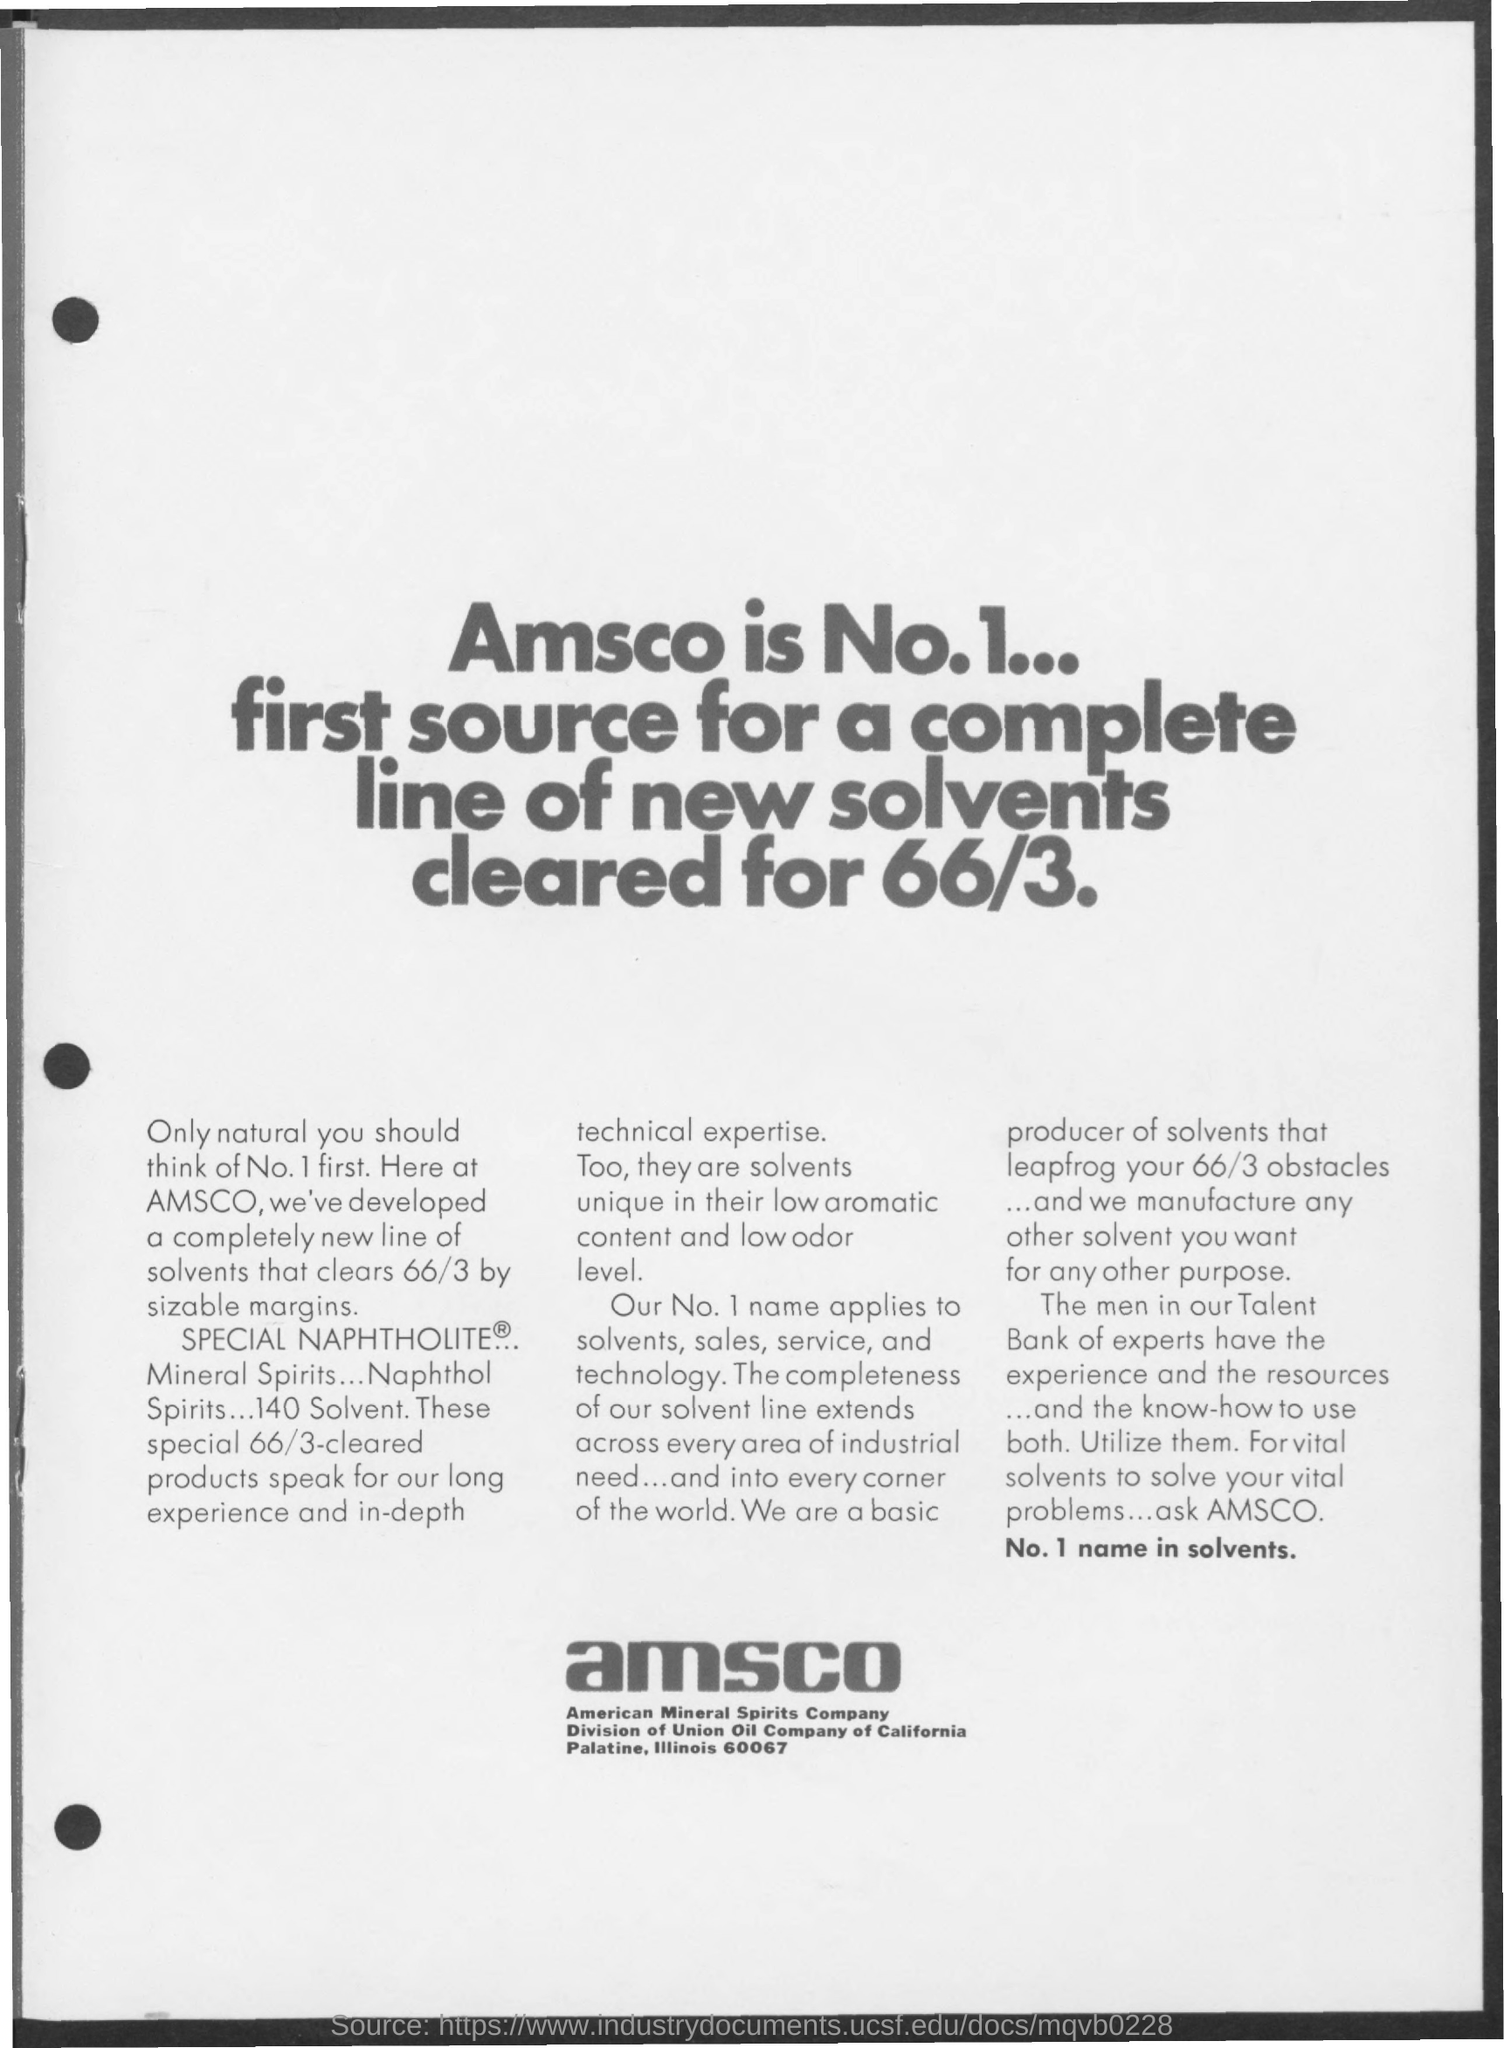Outline some significant characteristics in this image. American Mineral Spirits Company is a company that is commonly referred to as Amsco. 